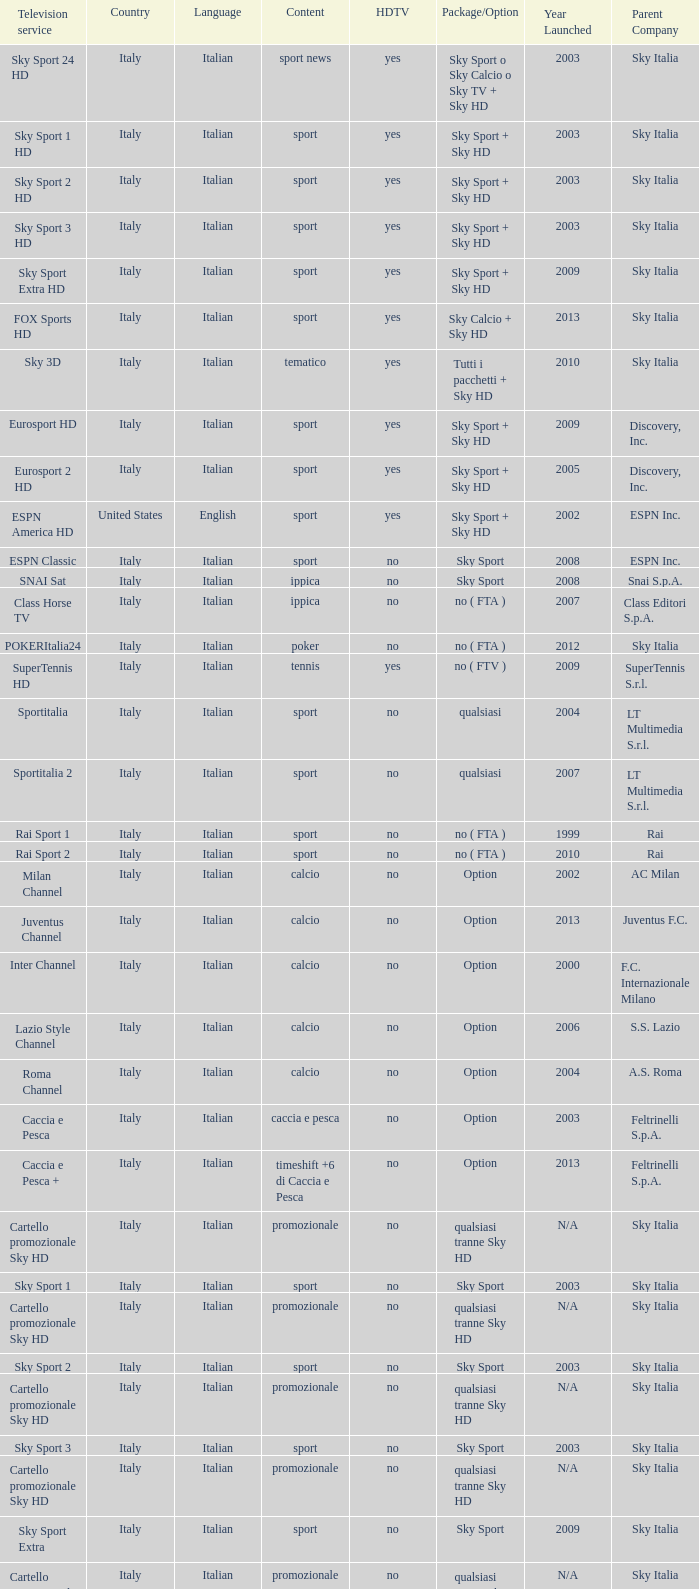What is Language, when Content is Sport, when HDTV is No, and when Television Service is ESPN America? Italian. 